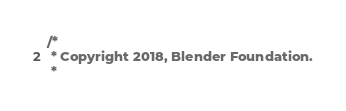Convert code to text. <code><loc_0><loc_0><loc_500><loc_500><_C++_>/*
 * Copyright 2018, Blender Foundation.
 *</code> 